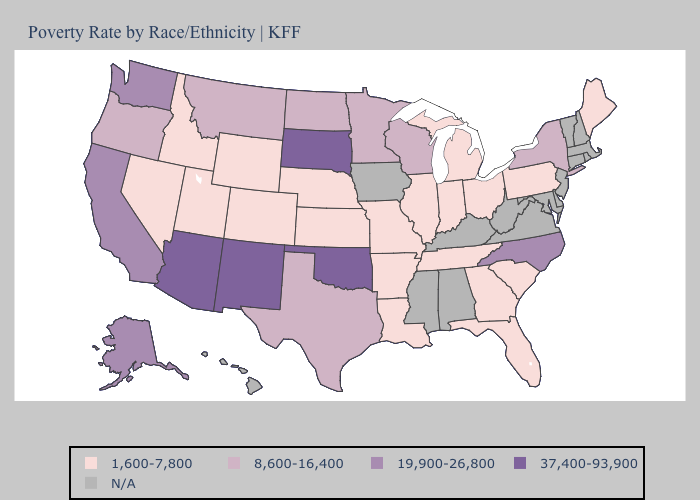What is the lowest value in the Northeast?
Quick response, please. 1,600-7,800. Which states have the lowest value in the MidWest?
Give a very brief answer. Illinois, Indiana, Kansas, Michigan, Missouri, Nebraska, Ohio. Does the map have missing data?
Concise answer only. Yes. Name the states that have a value in the range 37,400-93,900?
Keep it brief. Arizona, New Mexico, Oklahoma, South Dakota. What is the lowest value in the USA?
Quick response, please. 1,600-7,800. Among the states that border Montana , which have the lowest value?
Give a very brief answer. Idaho, Wyoming. What is the lowest value in the West?
Answer briefly. 1,600-7,800. Among the states that border South Carolina , does North Carolina have the lowest value?
Quick response, please. No. What is the lowest value in states that border Nevada?
Short answer required. 1,600-7,800. What is the value of Indiana?
Keep it brief. 1,600-7,800. Among the states that border New York , which have the lowest value?
Concise answer only. Pennsylvania. Name the states that have a value in the range N/A?
Be succinct. Alabama, Connecticut, Delaware, Hawaii, Iowa, Kentucky, Maryland, Massachusetts, Mississippi, New Hampshire, New Jersey, Rhode Island, Vermont, Virginia, West Virginia. What is the lowest value in the South?
Short answer required. 1,600-7,800. Name the states that have a value in the range N/A?
Keep it brief. Alabama, Connecticut, Delaware, Hawaii, Iowa, Kentucky, Maryland, Massachusetts, Mississippi, New Hampshire, New Jersey, Rhode Island, Vermont, Virginia, West Virginia. 